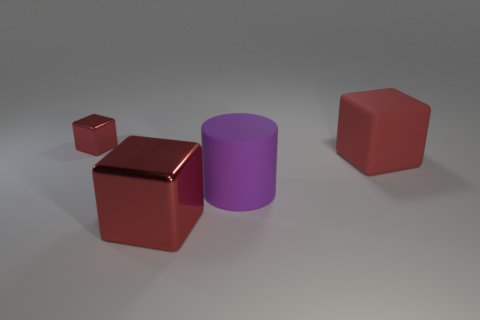Add 2 large green shiny cubes. How many objects exist? 6 Subtract all cylinders. How many objects are left? 3 Subtract 0 cyan blocks. How many objects are left? 4 Subtract all large things. Subtract all cylinders. How many objects are left? 0 Add 4 tiny red metallic blocks. How many tiny red metallic blocks are left? 5 Add 4 big matte blocks. How many big matte blocks exist? 5 